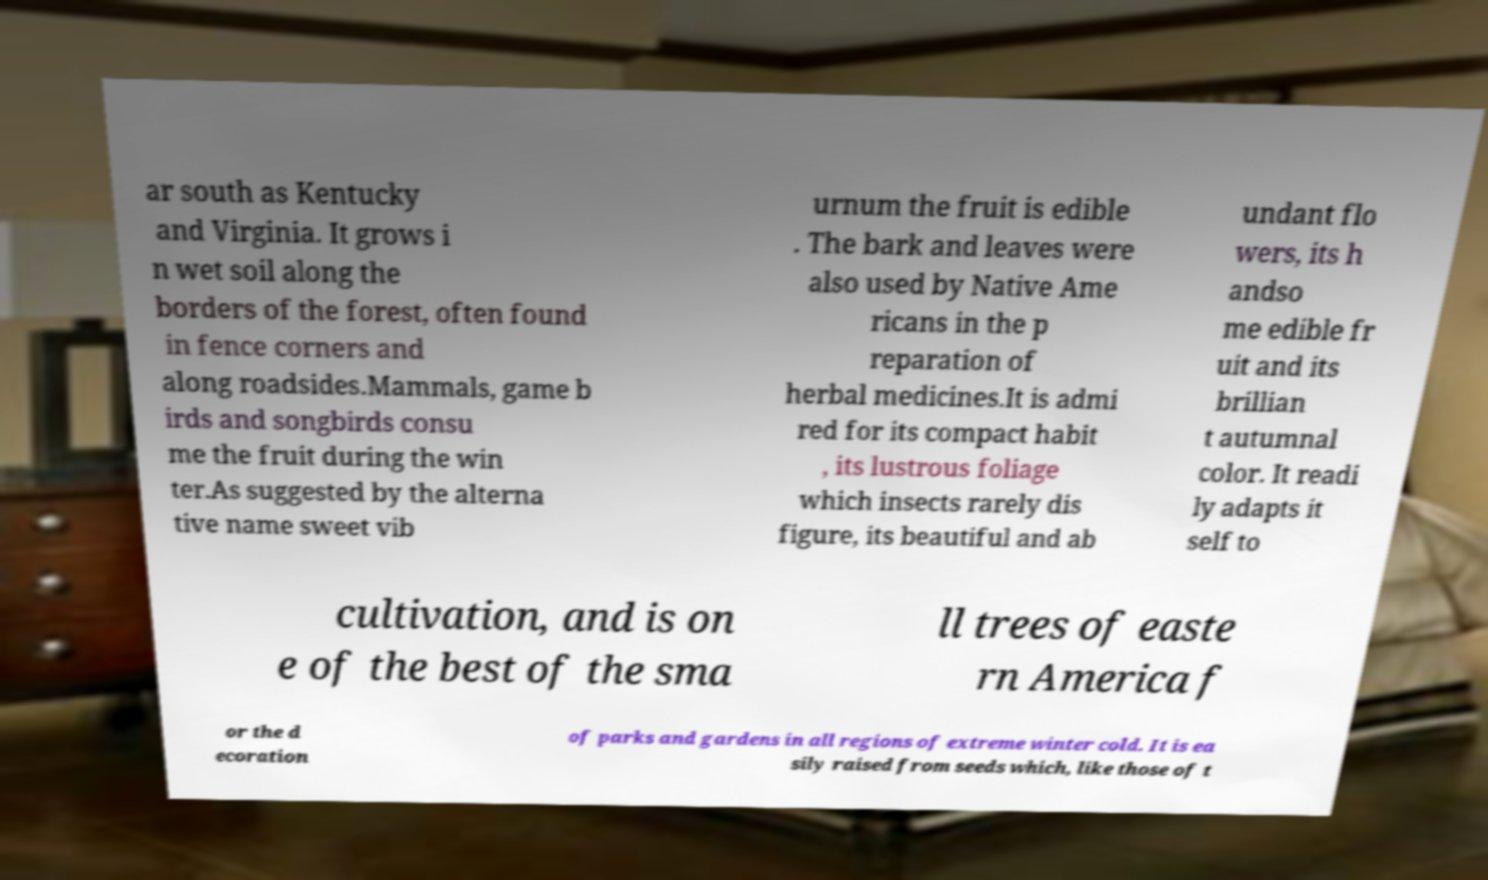Can you read and provide the text displayed in the image?This photo seems to have some interesting text. Can you extract and type it out for me? ar south as Kentucky and Virginia. It grows i n wet soil along the borders of the forest, often found in fence corners and along roadsides.Mammals, game b irds and songbirds consu me the fruit during the win ter.As suggested by the alterna tive name sweet vib urnum the fruit is edible . The bark and leaves were also used by Native Ame ricans in the p reparation of herbal medicines.It is admi red for its compact habit , its lustrous foliage which insects rarely dis figure, its beautiful and ab undant flo wers, its h andso me edible fr uit and its brillian t autumnal color. It readi ly adapts it self to cultivation, and is on e of the best of the sma ll trees of easte rn America f or the d ecoration of parks and gardens in all regions of extreme winter cold. It is ea sily raised from seeds which, like those of t 